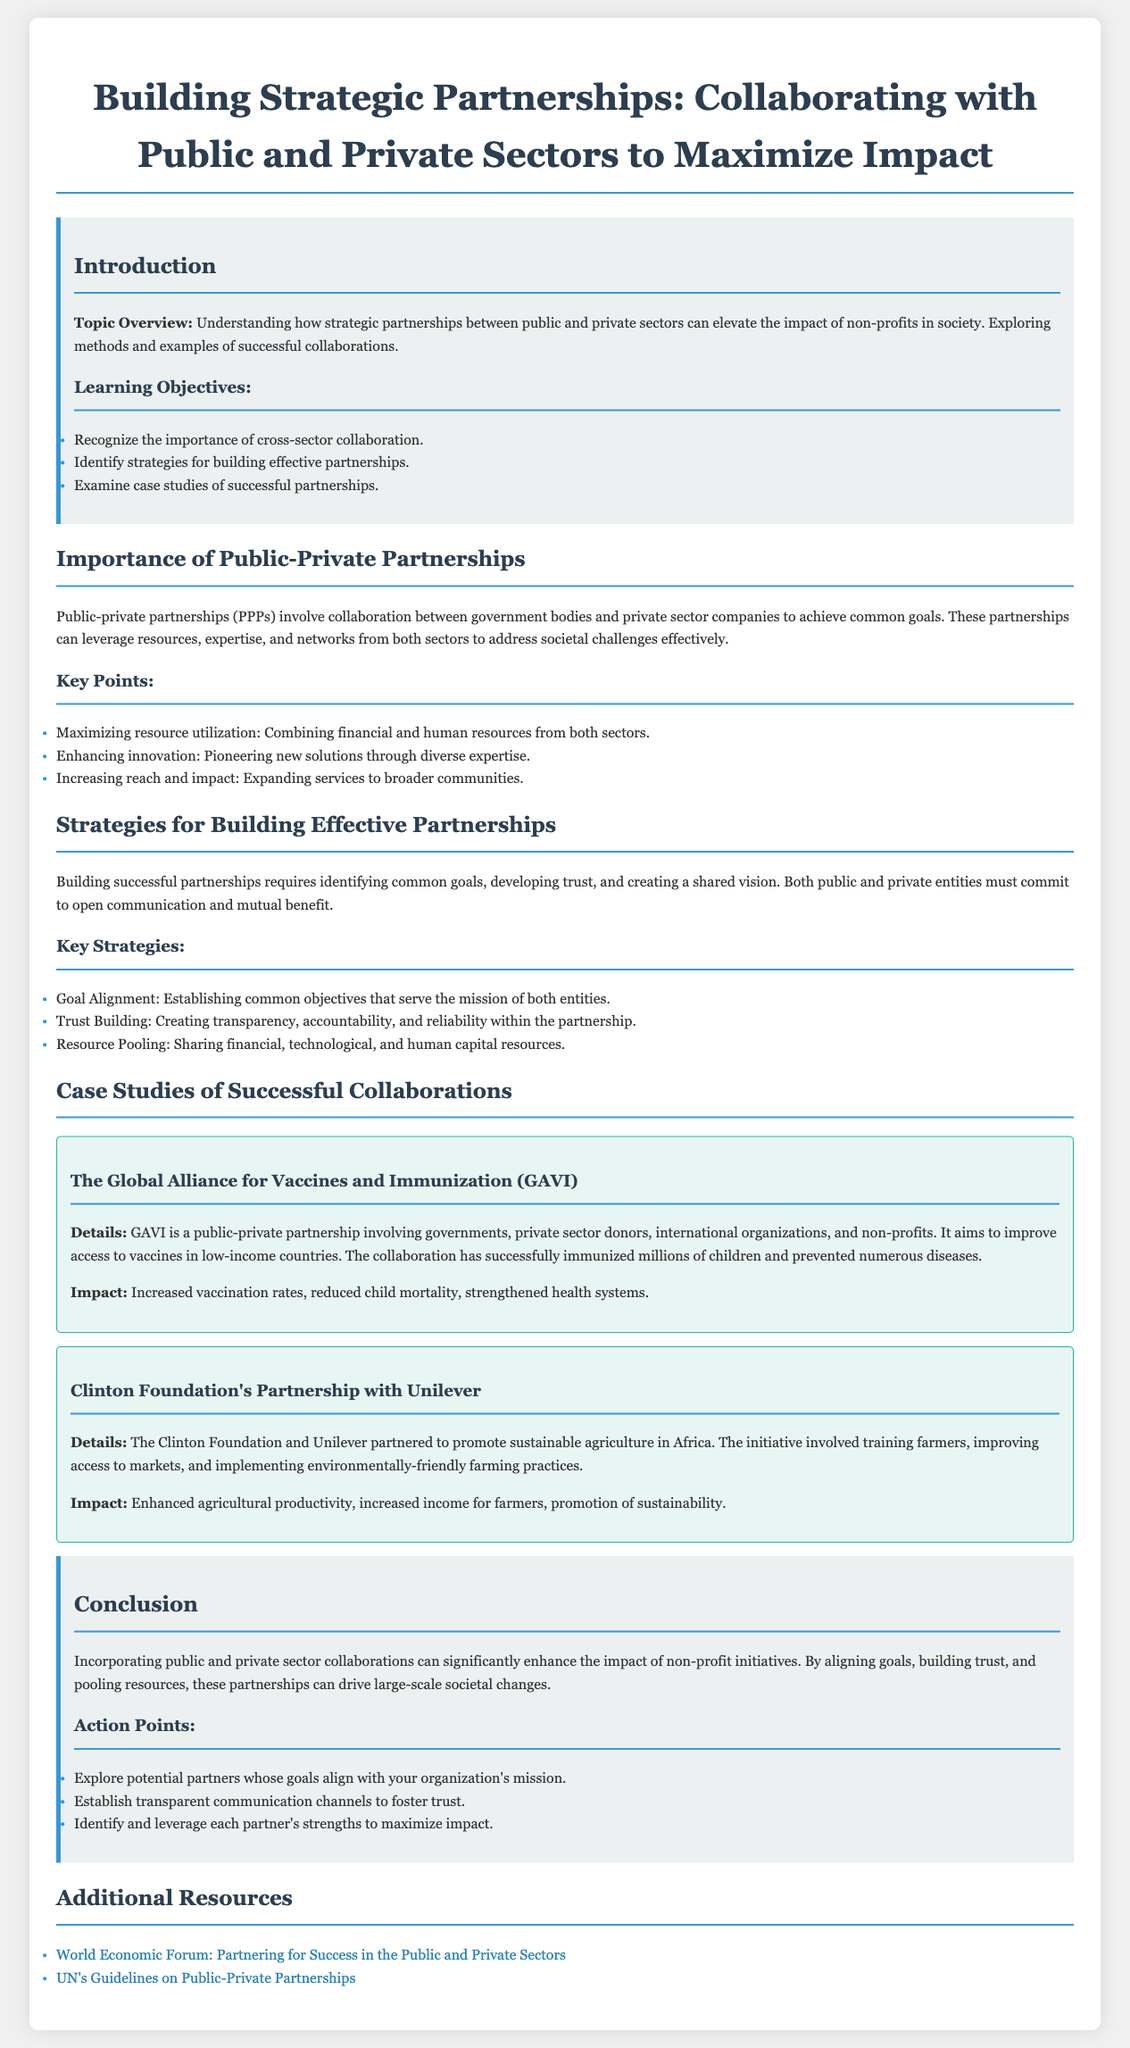What is the title of the lesson plan? The title of the lesson plan is typically found at the top of the document, and it specifies the main topic of discussion.
Answer: Building Strategic Partnerships: Collaborating with Public and Private Sectors What organization is involved in the case study with vaccination efforts? This information is derived from the case study section, which highlights specific partnerships and their goals.
Answer: GAVI What is one of the key strategies for building effective partnerships? The key strategies are outlined in a dedicated section, detailing how to create successful collaborations.
Answer: Trust Building How many learning objectives are listed in the document? The learning objectives are enumerated in the introductory section, indicating what participants should aim to achieve.
Answer: Three What type of partnership is mentioned in the overview? This term is usually highlighted while discussing the theme of cross-sector collaborations in the document.
Answer: Public-private partnerships What is one action point mentioned in the conclusion? Action points are practical suggestions provided at the end of the lesson plan, aiming to guide implementation.
Answer: Explore potential partners whose goals align with your organization's mission What impact did the Clinton Foundation's partnership with Unilever have? Each case study includes details about the results of the partnership, showcasing its effectiveness.
Answer: Enhanced agricultural productivity What color is used for the section heading styles? The color of the text for section headings is specified in the stylistic elements of the document.
Answer: #2c3e50 